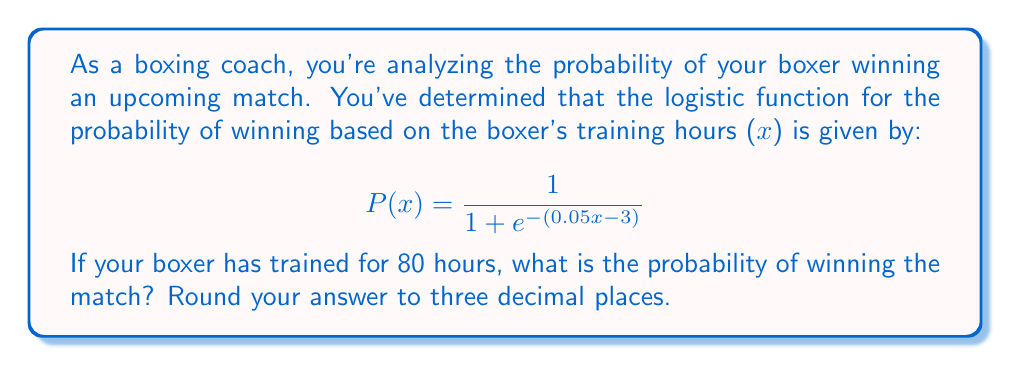What is the answer to this math problem? To solve this problem, we'll follow these steps:

1) We're given the logistic function:
   $$ P(x) = \frac{1}{1 + e^{-(0.05x - 3)}} $$

2) We need to substitute x = 80 (training hours) into this function:
   $$ P(80) = \frac{1}{1 + e^{-(0.05(80) - 3)}} $$

3) Let's simplify the expression inside the exponent:
   $$ 0.05(80) - 3 = 4 - 3 = 1 $$

4) Now our equation looks like:
   $$ P(80) = \frac{1}{1 + e^{-1}} $$

5) Calculate $e^{-1}$:
   $$ e^{-1} \approx 0.36788 $$

6) Substitute this value:
   $$ P(80) = \frac{1}{1 + 0.36788} = \frac{1}{1.36788} $$

7) Divide:
   $$ P(80) \approx 0.73106 $$

8) Rounding to three decimal places:
   $$ P(80) \approx 0.731 $$

Therefore, the probability of your boxer winning the match after 80 hours of training is approximately 0.731 or 73.1%.
Answer: 0.731 